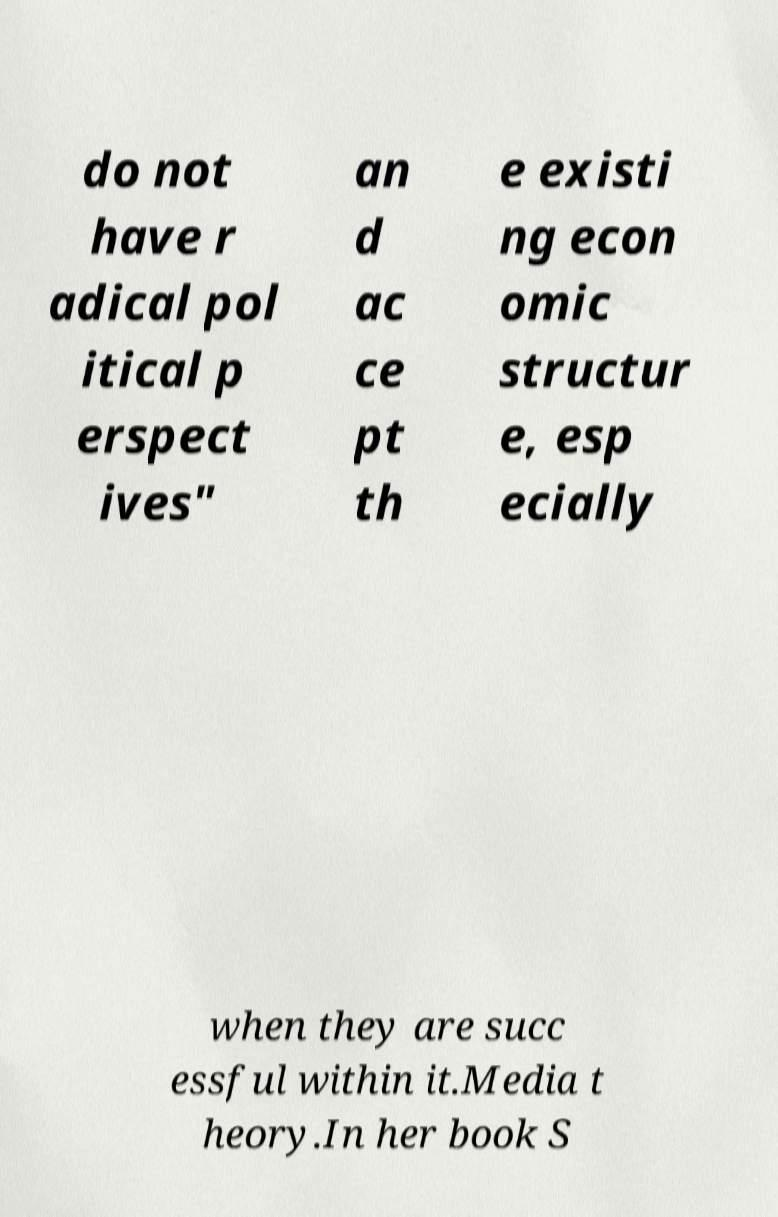What messages or text are displayed in this image? I need them in a readable, typed format. do not have r adical pol itical p erspect ives" an d ac ce pt th e existi ng econ omic structur e, esp ecially when they are succ essful within it.Media t heory.In her book S 